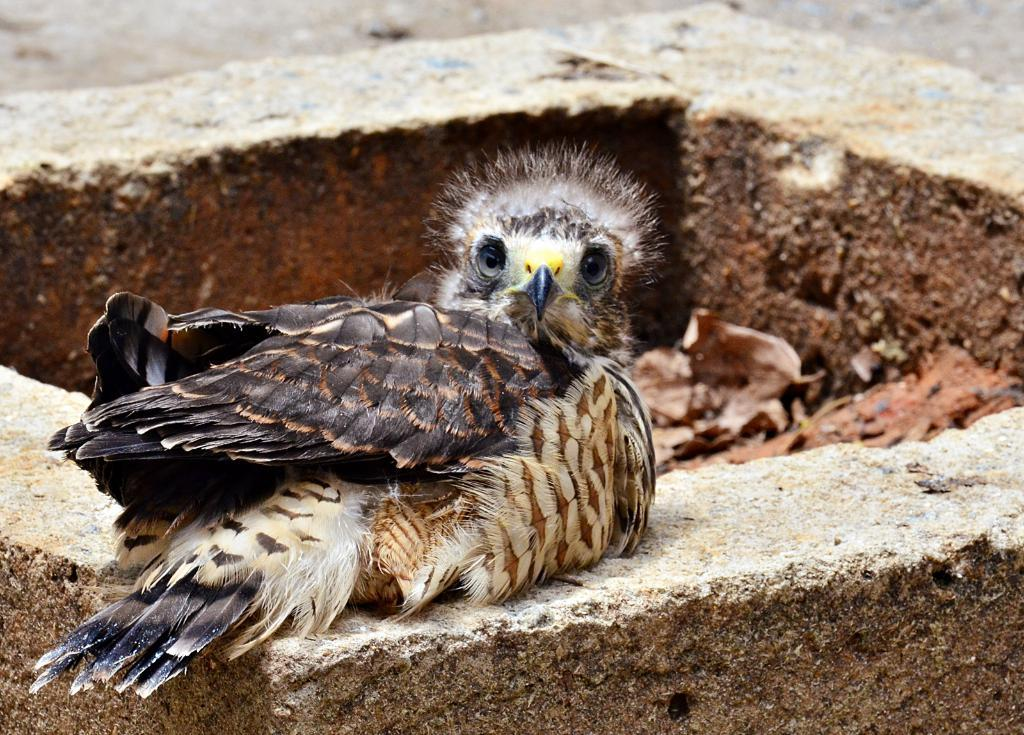What type of bird is in the image? There is a golden eagle in the image. Can you describe the appearance of the bird? The golden eagle has a brown body with a golden-brown head and neck. What is the bird's habitat or natural environment? Golden eagles are typically found in mountainous regions, forests, and grasslands. What type of donkey can be seen guiding the golden eagle in the image? There is no donkey present in the image, nor is there any indication that the golden eagle is being guided by any animal. 